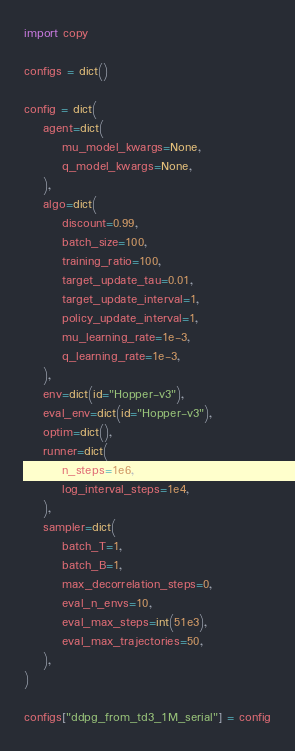<code> <loc_0><loc_0><loc_500><loc_500><_Python_>
import copy

configs = dict()

config = dict(
    agent=dict(
        mu_model_kwargs=None,
        q_model_kwargs=None,
    ),
    algo=dict(
        discount=0.99,
        batch_size=100,
        training_ratio=100,
        target_update_tau=0.01,
        target_update_interval=1,
        policy_update_interval=1,
        mu_learning_rate=1e-3,
        q_learning_rate=1e-3,
    ),
    env=dict(id="Hopper-v3"),
    eval_env=dict(id="Hopper-v3"),
    optim=dict(),
    runner=dict(
        n_steps=1e6,
        log_interval_steps=1e4,
    ),
    sampler=dict(
        batch_T=1,
        batch_B=1,
        max_decorrelation_steps=0,
        eval_n_envs=10,
        eval_max_steps=int(51e3),
        eval_max_trajectories=50,
    ),
)

configs["ddpg_from_td3_1M_serial"] = config
</code> 